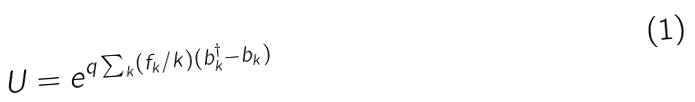<formula> <loc_0><loc_0><loc_500><loc_500>U = e ^ { q \sum _ { k } ( f _ { k } / k ) ( b _ { k } ^ { \dagger } - b _ { k } ) }</formula> 